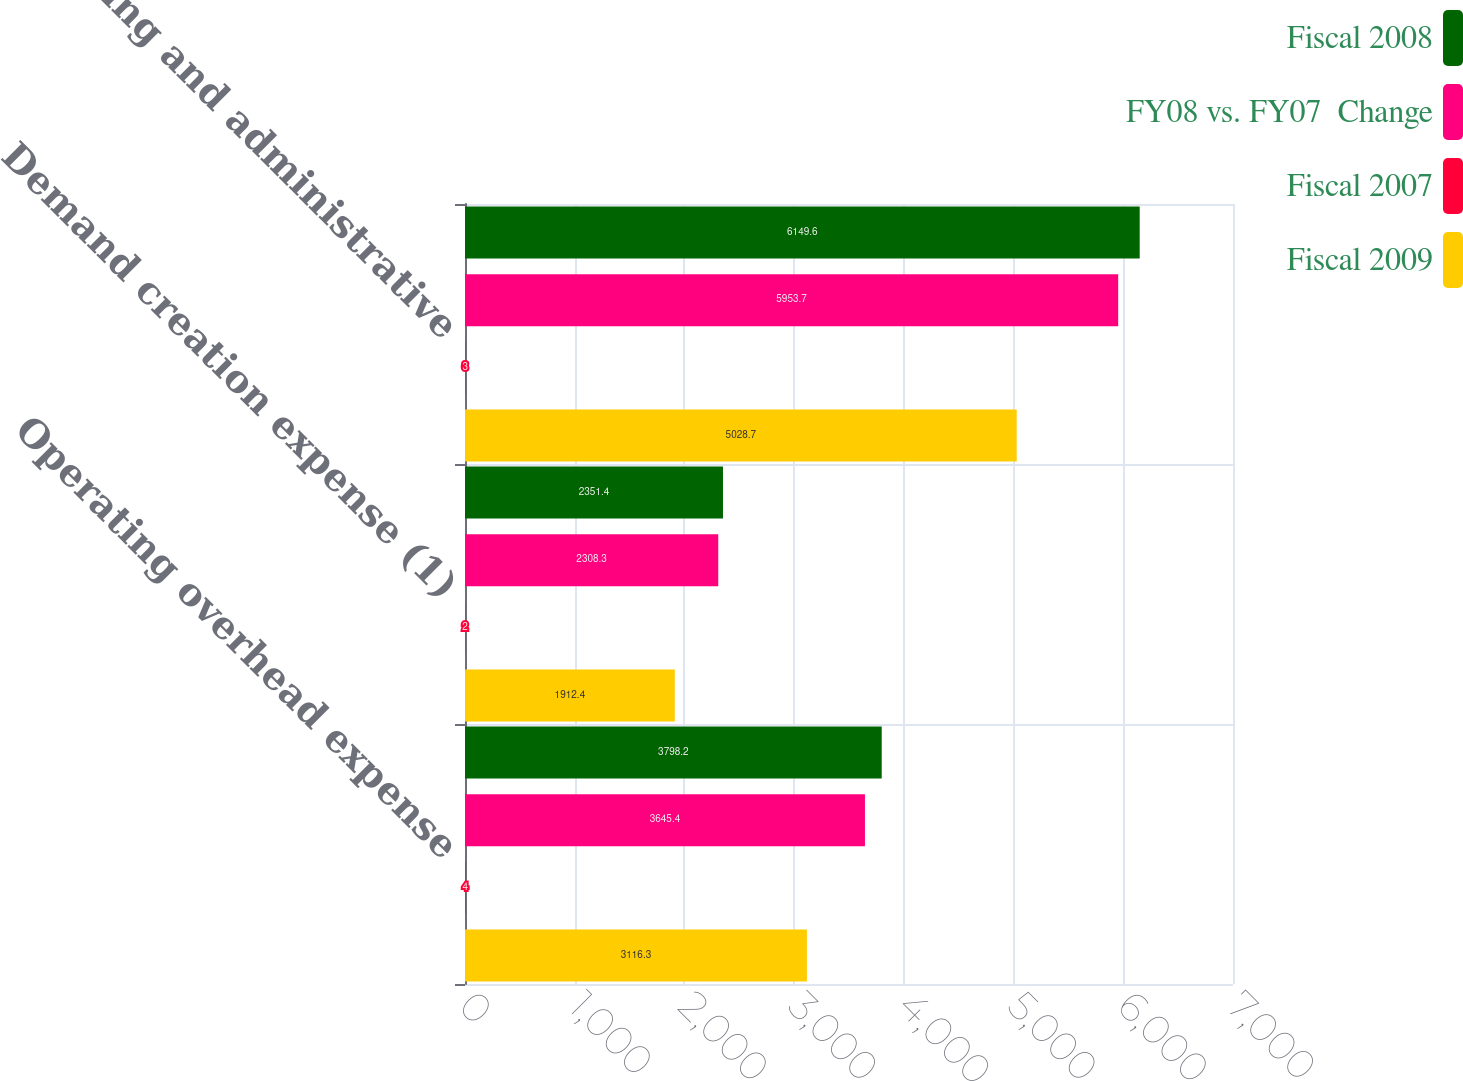<chart> <loc_0><loc_0><loc_500><loc_500><stacked_bar_chart><ecel><fcel>Operating overhead expense<fcel>Demand creation expense (1)<fcel>Selling and administrative<nl><fcel>Fiscal 2008<fcel>3798.2<fcel>2351.4<fcel>6149.6<nl><fcel>FY08 vs. FY07  Change<fcel>3645.4<fcel>2308.3<fcel>5953.7<nl><fcel>Fiscal 2007<fcel>4<fcel>2<fcel>3<nl><fcel>Fiscal 2009<fcel>3116.3<fcel>1912.4<fcel>5028.7<nl></chart> 